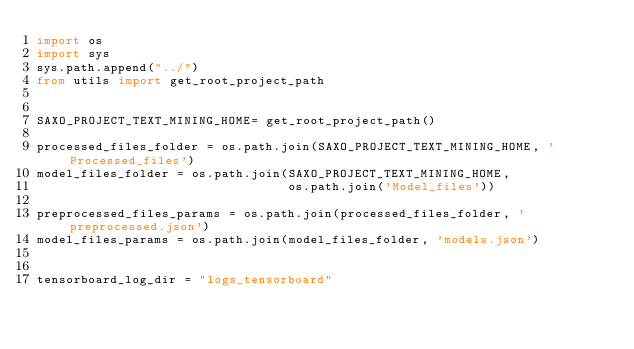<code> <loc_0><loc_0><loc_500><loc_500><_Python_>import os
import sys
sys.path.append("../")
from utils import get_root_project_path


SAXO_PROJECT_TEXT_MINING_HOME= get_root_project_path()

processed_files_folder = os.path.join(SAXO_PROJECT_TEXT_MINING_HOME, 'Processed_files')
model_files_folder = os.path.join(SAXO_PROJECT_TEXT_MINING_HOME,
                                  os.path.join('Model_files'))

preprocessed_files_params = os.path.join(processed_files_folder, 'preprocessed.json')
model_files_params = os.path.join(model_files_folder, 'models.json')


tensorboard_log_dir = "logs_tensorboard"</code> 